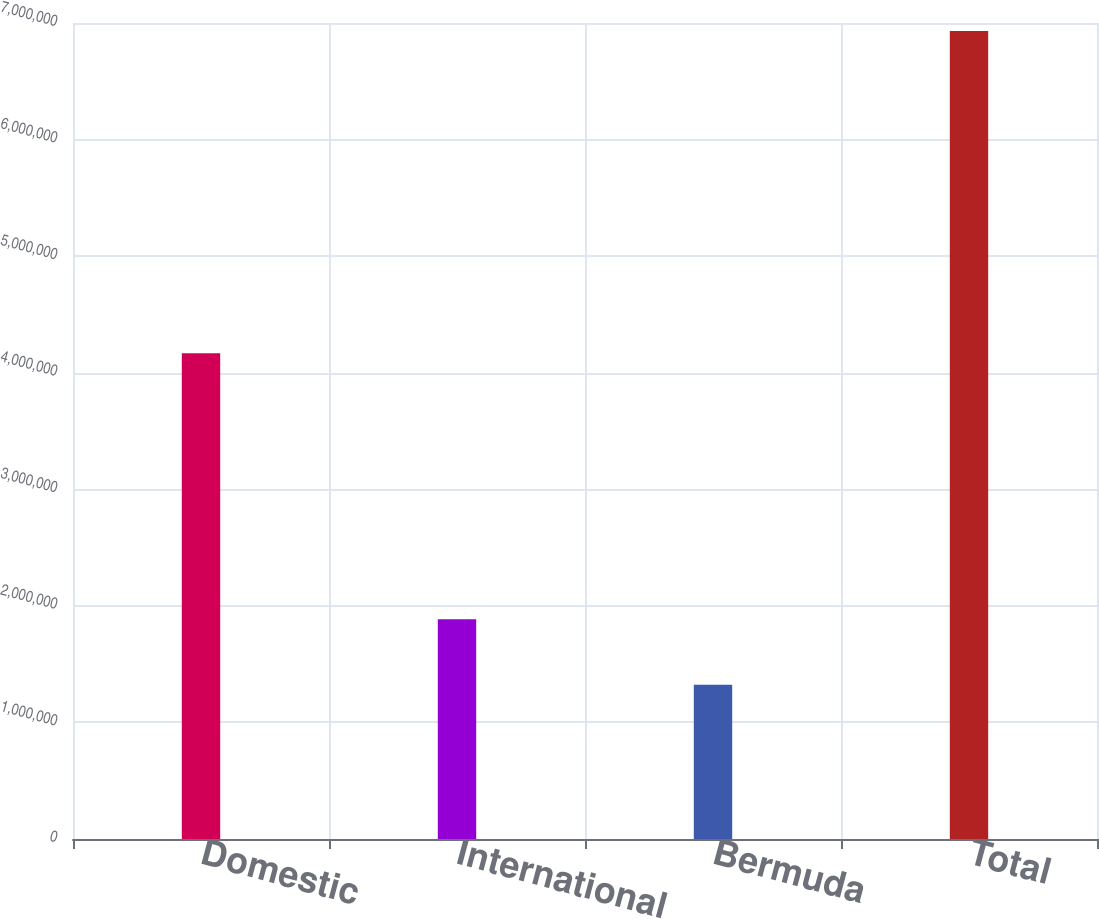Convert chart to OTSL. <chart><loc_0><loc_0><loc_500><loc_500><bar_chart><fcel>Domestic<fcel>International<fcel>Bermuda<fcel>Total<nl><fcel>4.16762e+06<fcel>1.88495e+06<fcel>1.3242e+06<fcel>6.9317e+06<nl></chart> 